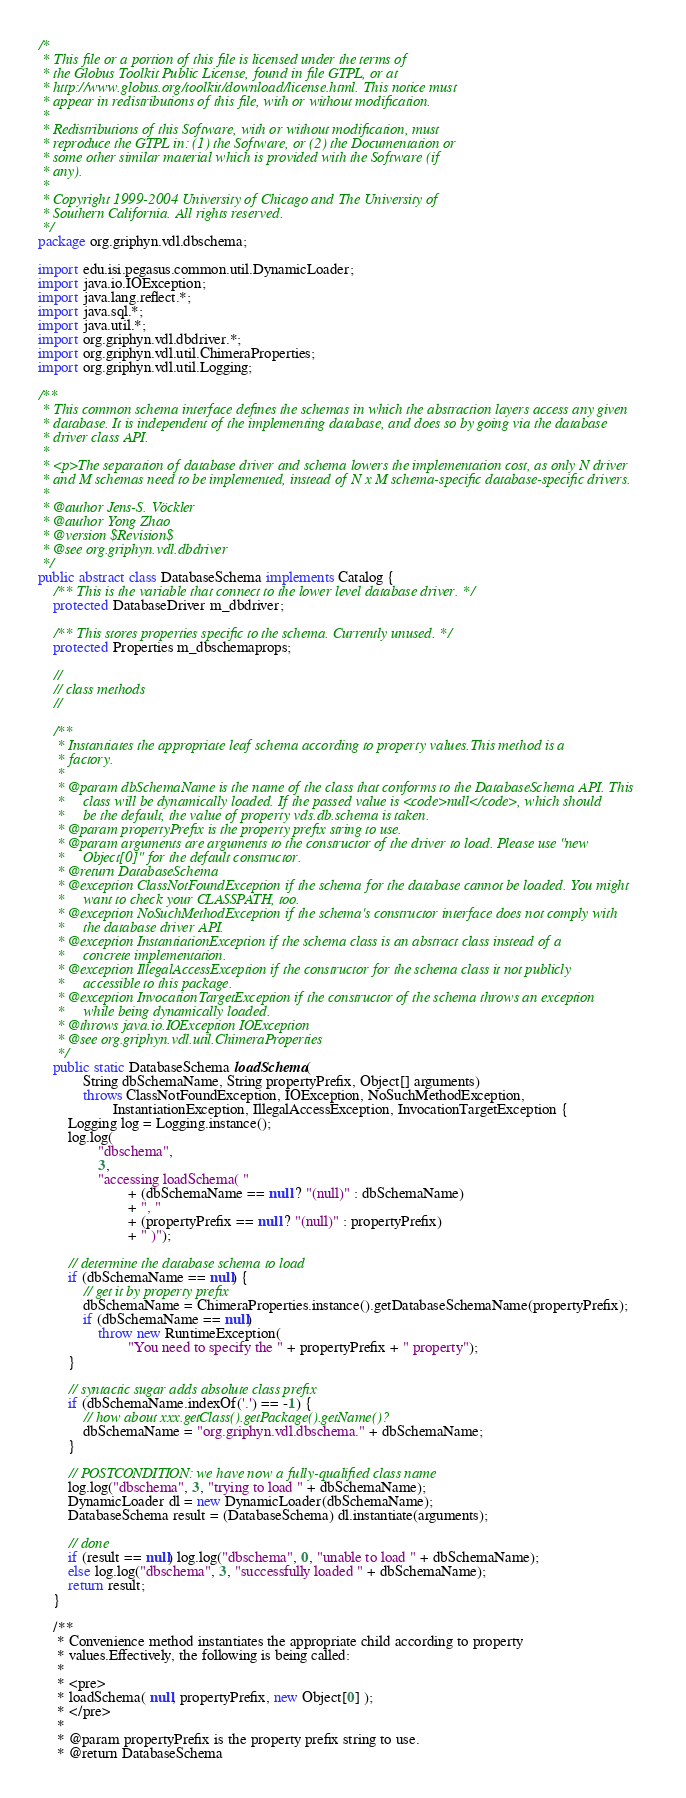<code> <loc_0><loc_0><loc_500><loc_500><_Java_>/*
 * This file or a portion of this file is licensed under the terms of
 * the Globus Toolkit Public License, found in file GTPL, or at
 * http://www.globus.org/toolkit/download/license.html. This notice must
 * appear in redistributions of this file, with or without modification.
 *
 * Redistributions of this Software, with or without modification, must
 * reproduce the GTPL in: (1) the Software, or (2) the Documentation or
 * some other similar material which is provided with the Software (if
 * any).
 *
 * Copyright 1999-2004 University of Chicago and The University of
 * Southern California. All rights reserved.
 */
package org.griphyn.vdl.dbschema;

import edu.isi.pegasus.common.util.DynamicLoader;
import java.io.IOException;
import java.lang.reflect.*;
import java.sql.*;
import java.util.*;
import org.griphyn.vdl.dbdriver.*;
import org.griphyn.vdl.util.ChimeraProperties;
import org.griphyn.vdl.util.Logging;

/**
 * This common schema interface defines the schemas in which the abstraction layers access any given
 * database. It is independent of the implementing database, and does so by going via the database
 * driver class API.
 *
 * <p>The separation of database driver and schema lowers the implementation cost, as only N driver
 * and M schemas need to be implemented, instead of N x M schema-specific database-specific drivers.
 *
 * @author Jens-S. Vöckler
 * @author Yong Zhao
 * @version $Revision$
 * @see org.griphyn.vdl.dbdriver
 */
public abstract class DatabaseSchema implements Catalog {
    /** This is the variable that connect to the lower level database driver. */
    protected DatabaseDriver m_dbdriver;

    /** This stores properties specific to the schema. Currently unused. */
    protected Properties m_dbschemaprops;

    //
    // class methods
    //

    /**
     * Instantiates the appropriate leaf schema according to property values.This method is a
     * factory.
     *
     * @param dbSchemaName is the name of the class that conforms to the DatabaseSchema API. This
     *     class will be dynamically loaded. If the passed value is <code>null</code>, which should
     *     be the default, the value of property vds.db.schema is taken.
     * @param propertyPrefix is the property prefix string to use.
     * @param arguments are arguments to the constructor of the driver to load. Please use "new
     *     Object[0]" for the default constructor.
     * @return DatabaseSchema
     * @exception ClassNotFoundException if the schema for the database cannot be loaded. You might
     *     want to check your CLASSPATH, too.
     * @exception NoSuchMethodException if the schema's constructor interface does not comply with
     *     the database driver API.
     * @exception InstantiationException if the schema class is an abstract class instead of a
     *     concrete implementation.
     * @exception IllegalAccessException if the constructor for the schema class it not publicly
     *     accessible to this package.
     * @exception InvocationTargetException if the constructor of the schema throws an exception
     *     while being dynamically loaded.
     * @throws java.io.IOException IOException
     * @see org.griphyn.vdl.util.ChimeraProperties
     */
    public static DatabaseSchema loadSchema(
            String dbSchemaName, String propertyPrefix, Object[] arguments)
            throws ClassNotFoundException, IOException, NoSuchMethodException,
                    InstantiationException, IllegalAccessException, InvocationTargetException {
        Logging log = Logging.instance();
        log.log(
                "dbschema",
                3,
                "accessing loadSchema( "
                        + (dbSchemaName == null ? "(null)" : dbSchemaName)
                        + ", "
                        + (propertyPrefix == null ? "(null)" : propertyPrefix)
                        + " )");

        // determine the database schema to load
        if (dbSchemaName == null) {
            // get it by property prefix
            dbSchemaName = ChimeraProperties.instance().getDatabaseSchemaName(propertyPrefix);
            if (dbSchemaName == null)
                throw new RuntimeException(
                        "You need to specify the " + propertyPrefix + " property");
        }

        // syntactic sugar adds absolute class prefix
        if (dbSchemaName.indexOf('.') == -1) {
            // how about xxx.getClass().getPackage().getName()?
            dbSchemaName = "org.griphyn.vdl.dbschema." + dbSchemaName;
        }

        // POSTCONDITION: we have now a fully-qualified class name
        log.log("dbschema", 3, "trying to load " + dbSchemaName);
        DynamicLoader dl = new DynamicLoader(dbSchemaName);
        DatabaseSchema result = (DatabaseSchema) dl.instantiate(arguments);

        // done
        if (result == null) log.log("dbschema", 0, "unable to load " + dbSchemaName);
        else log.log("dbschema", 3, "successfully loaded " + dbSchemaName);
        return result;
    }

    /**
     * Convenience method instantiates the appropriate child according to property
     * values.Effectively, the following is being called:
     *
     * <pre>
     * loadSchema( null, propertyPrefix, new Object[0] );
     * </pre>
     *
     * @param propertyPrefix is the property prefix string to use.
     * @return DatabaseSchema</code> 